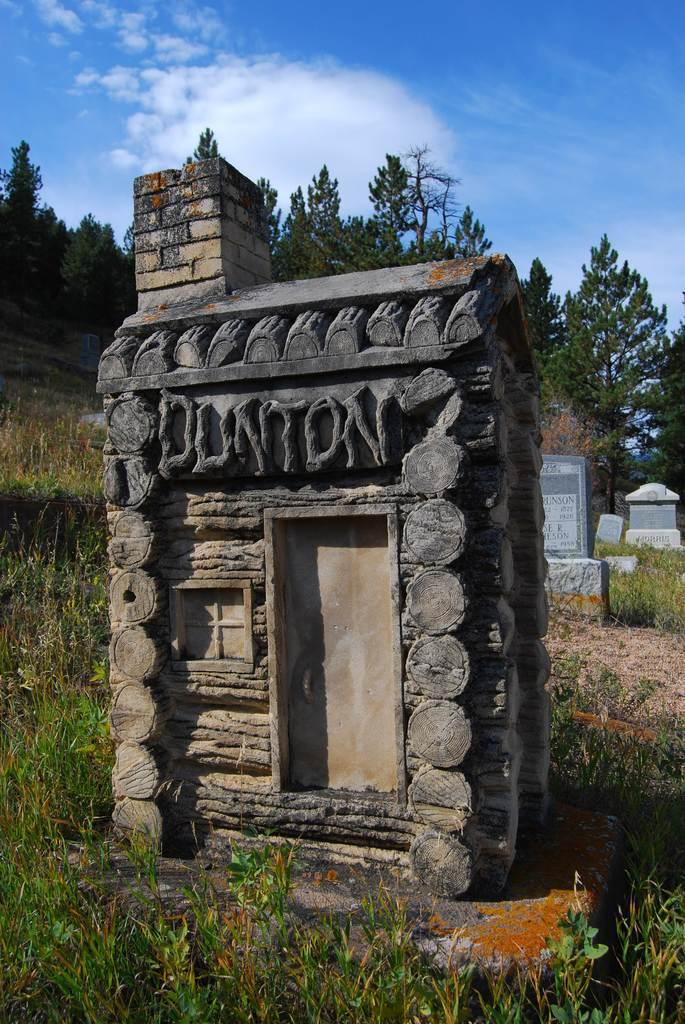Provide a one-sentence caption for the provided image. a small house with the name 'Dunton' etched into the top of it. 